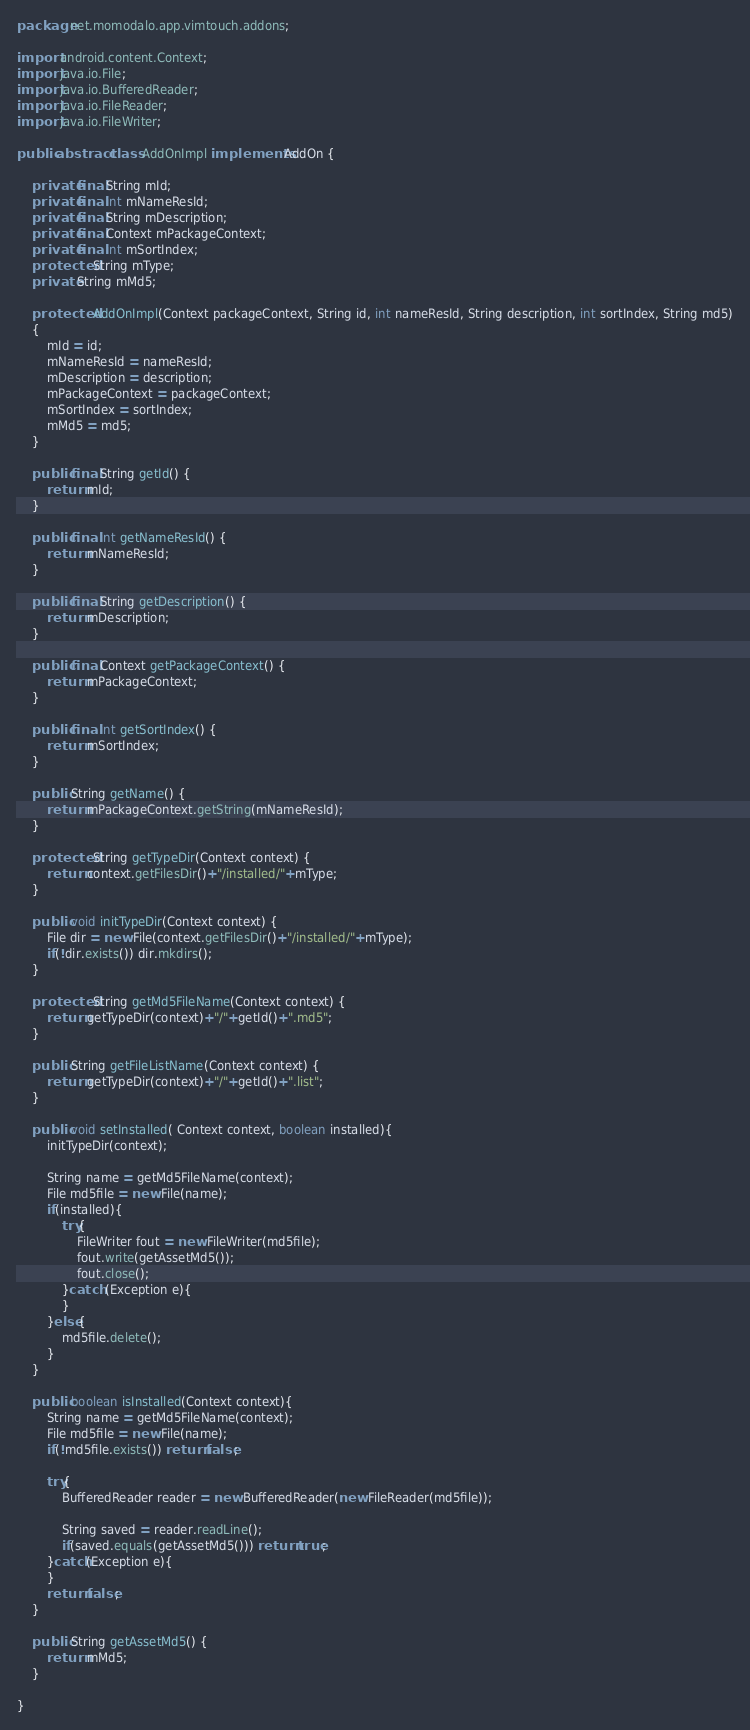<code> <loc_0><loc_0><loc_500><loc_500><_Java_>package net.momodalo.app.vimtouch.addons;

import android.content.Context;
import java.io.File;
import java.io.BufferedReader;
import java.io.FileReader;
import java.io.FileWriter;

public abstract class AddOnImpl implements AddOn {

	private final String mId;
    private final int mNameResId;
    private final String mDescription;
    private final Context mPackageContext;
    private final int mSortIndex;
    protected String mType;
    private String mMd5;
    
    protected AddOnImpl(Context packageContext, String id, int nameResId, String description, int sortIndex, String md5)
    {
    	mId = id;
    	mNameResId = nameResId;
    	mDescription = description;
    	mPackageContext = packageContext;
    	mSortIndex = sortIndex;
        mMd5 = md5;
    }
    
	public final String getId() {
		return mId;
	}

	public final int getNameResId() {
		return mNameResId;
	}

	public final String getDescription() {
		return mDescription;
	}

	public final Context getPackageContext() {
		return mPackageContext;
	}

	public final int getSortIndex() {
		return mSortIndex;
	}

	public String getName() {
		return mPackageContext.getString(mNameResId);
	}

    protected String getTypeDir(Context context) {
        return context.getFilesDir()+"/installed/"+mType;
    }

    public void initTypeDir(Context context) {
        File dir = new File(context.getFilesDir()+"/installed/"+mType);
        if(!dir.exists()) dir.mkdirs();
    }

    protected String getMd5FileName(Context context) {
        return getTypeDir(context)+"/"+getId()+".md5";
    }

    public String getFileListName(Context context) {
        return getTypeDir(context)+"/"+getId()+".list";
    }

    public void setInstalled( Context context, boolean installed){
        initTypeDir(context);

        String name = getMd5FileName(context); 
        File md5file = new File(name);
        if(installed){
            try{
                FileWriter fout = new FileWriter(md5file);
                fout.write(getAssetMd5());
                fout.close();
            }catch (Exception e){
            }
        }else{
            md5file.delete();
        }
    }

    public boolean isInstalled(Context context){
        String name = getMd5FileName(context); 
        File md5file = new File(name);
        if(!md5file.exists()) return false;

        try{
            BufferedReader reader = new BufferedReader(new FileReader(md5file));

            String saved = reader.readLine();
            if(saved.equals(getAssetMd5())) return true;
        }catch(Exception e){
        }
        return false;
    }

    public String getAssetMd5() {
        return mMd5;
    }

}
</code> 